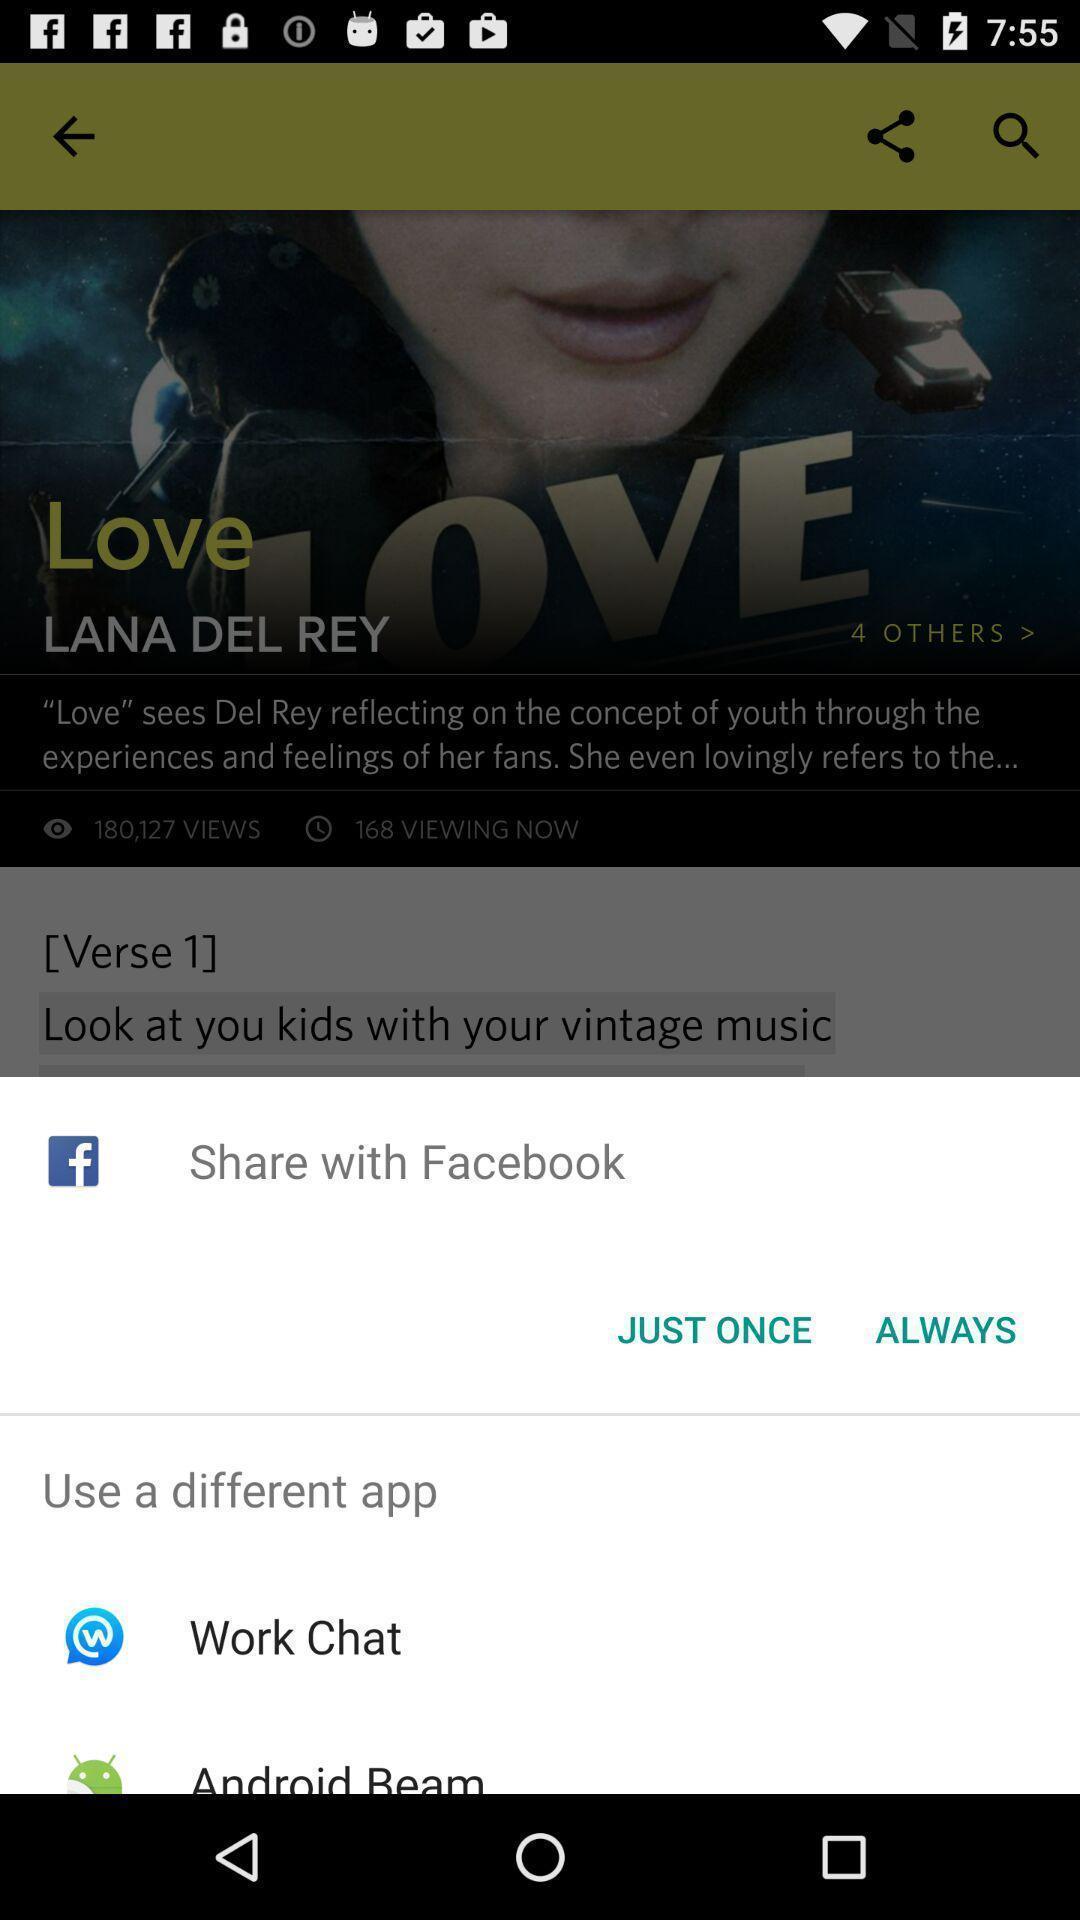Explain the elements present in this screenshot. Push up page showing app preference to share. 